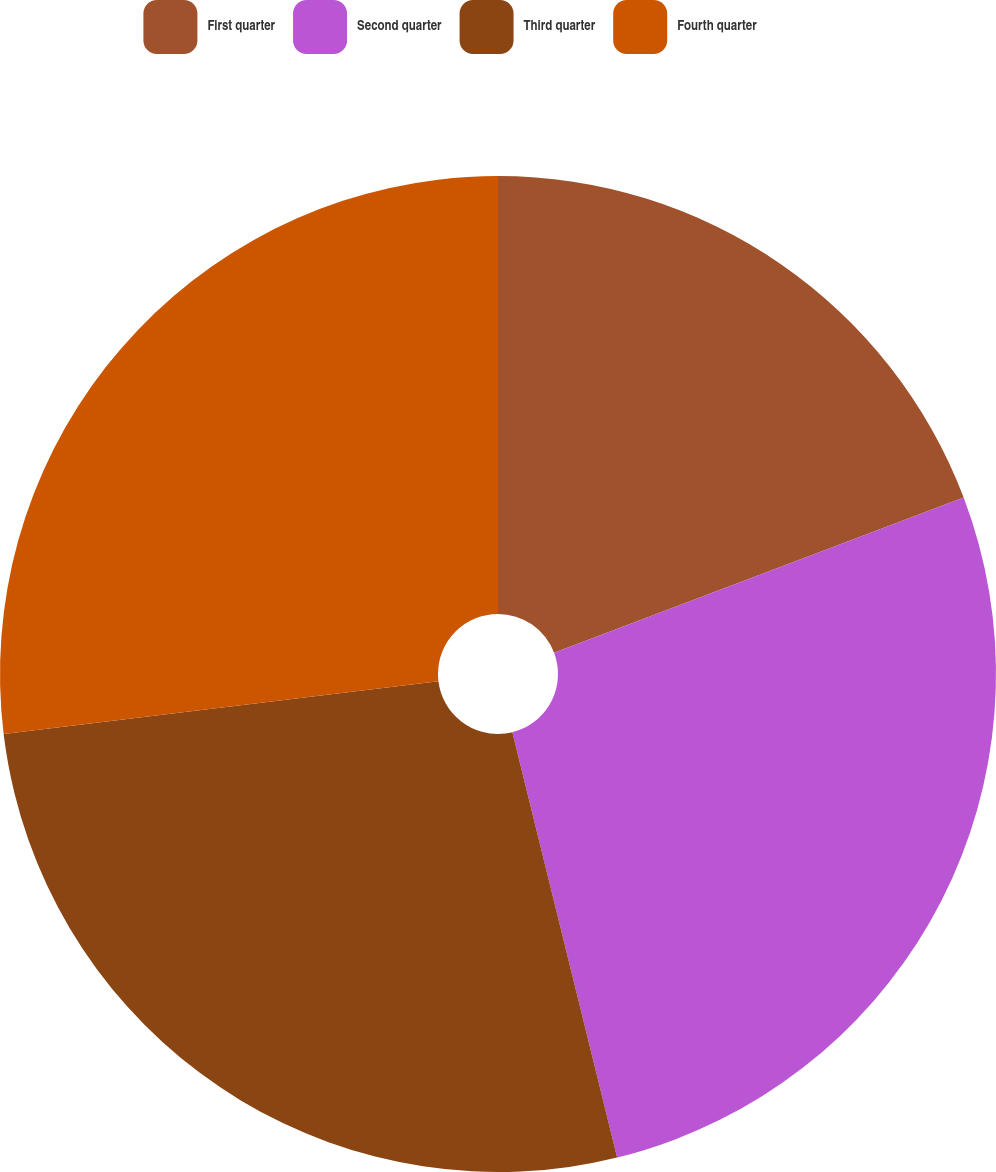Convert chart. <chart><loc_0><loc_0><loc_500><loc_500><pie_chart><fcel>First quarter<fcel>Second quarter<fcel>Third quarter<fcel>Fourth quarter<nl><fcel>19.23%<fcel>26.92%<fcel>26.92%<fcel>26.92%<nl></chart> 